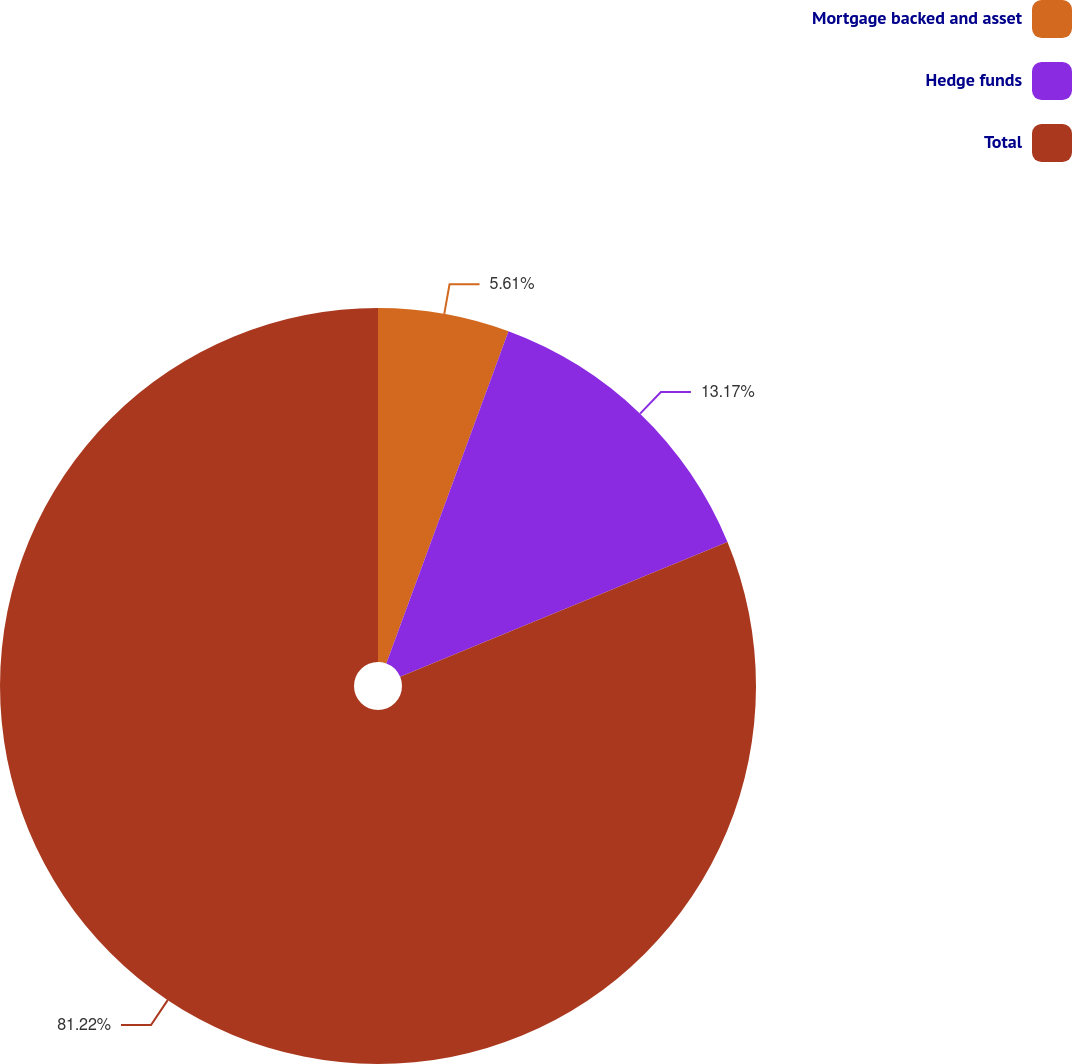Convert chart to OTSL. <chart><loc_0><loc_0><loc_500><loc_500><pie_chart><fcel>Mortgage backed and asset<fcel>Hedge funds<fcel>Total<nl><fcel>5.61%<fcel>13.17%<fcel>81.22%<nl></chart> 